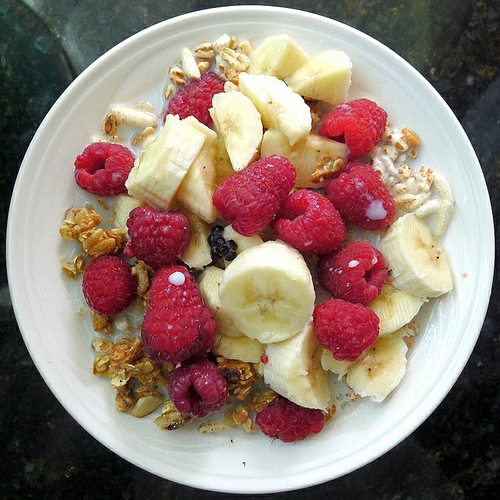<image>
Can you confirm if the berry is on the banana? Yes. Looking at the image, I can see the berry is positioned on top of the banana, with the banana providing support. Is the banana on the table? No. The banana is not positioned on the table. They may be near each other, but the banana is not supported by or resting on top of the table. Is the banana slice under the raspberry? No. The banana slice is not positioned under the raspberry. The vertical relationship between these objects is different. 